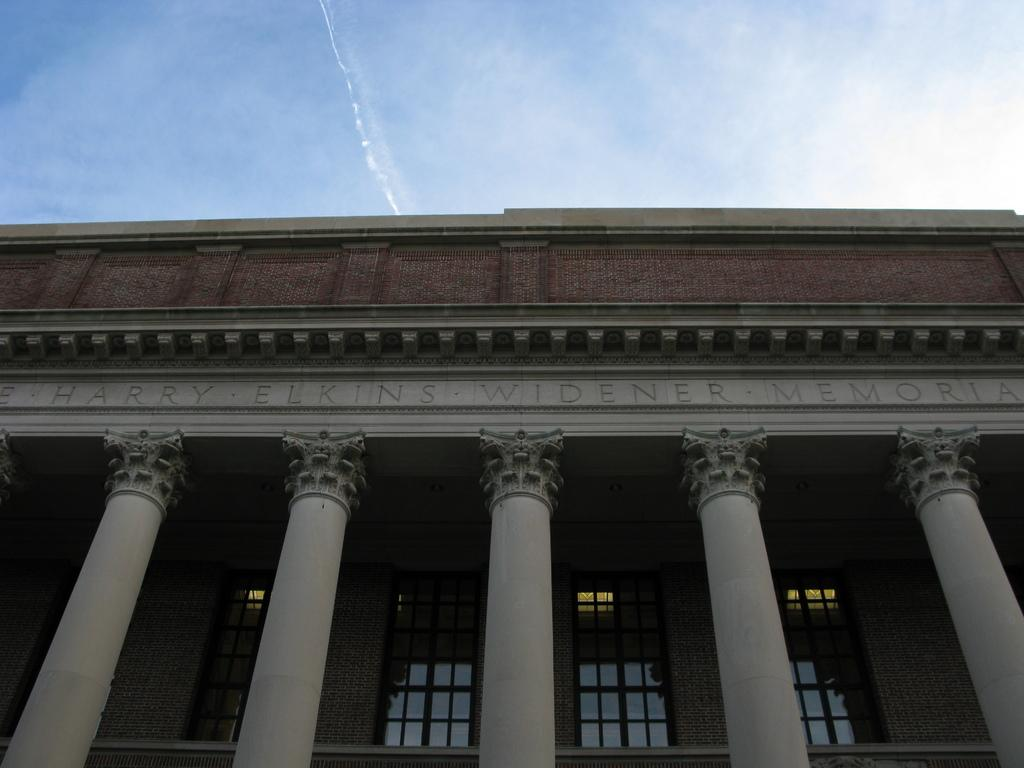What architectural features can be seen on the building in the image? There are windows and pillars in the building. Is there any text or information visible on the building? Yes, something is written on the building. What can be seen in the background of the image? There are clouds and the sky is blue in the background of the image. What type of cannon is visible on the building in the image? There is no cannon present on the building in the image. What view can be seen from the windows of the building? The provided facts do not give information about the view from the windows, so it cannot be determined from the image. 